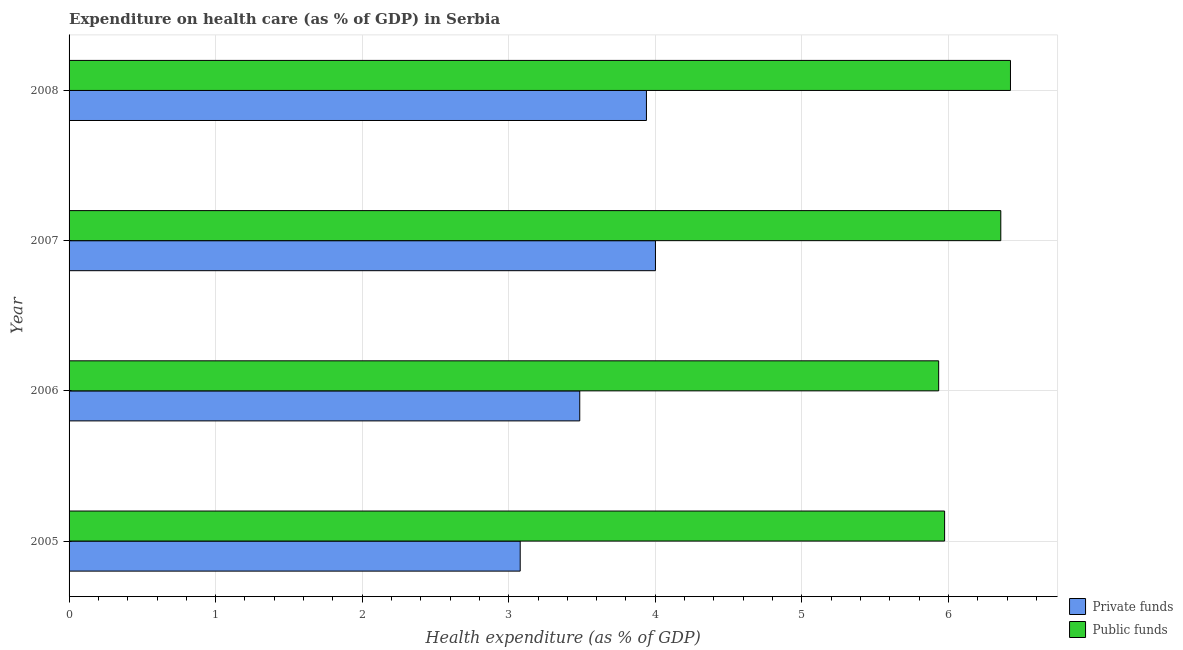Are the number of bars on each tick of the Y-axis equal?
Give a very brief answer. Yes. How many bars are there on the 1st tick from the top?
Your response must be concise. 2. How many bars are there on the 2nd tick from the bottom?
Provide a short and direct response. 2. In how many cases, is the number of bars for a given year not equal to the number of legend labels?
Provide a short and direct response. 0. What is the amount of private funds spent in healthcare in 2007?
Provide a succinct answer. 4. Across all years, what is the maximum amount of private funds spent in healthcare?
Your response must be concise. 4. Across all years, what is the minimum amount of public funds spent in healthcare?
Your response must be concise. 5.93. In which year was the amount of public funds spent in healthcare maximum?
Provide a succinct answer. 2008. In which year was the amount of private funds spent in healthcare minimum?
Your response must be concise. 2005. What is the total amount of public funds spent in healthcare in the graph?
Give a very brief answer. 24.69. What is the difference between the amount of public funds spent in healthcare in 2007 and that in 2008?
Provide a succinct answer. -0.07. What is the difference between the amount of public funds spent in healthcare in 2006 and the amount of private funds spent in healthcare in 2007?
Your response must be concise. 1.93. What is the average amount of private funds spent in healthcare per year?
Offer a terse response. 3.63. In the year 2008, what is the difference between the amount of private funds spent in healthcare and amount of public funds spent in healthcare?
Offer a terse response. -2.48. In how many years, is the amount of public funds spent in healthcare greater than 5.2 %?
Offer a terse response. 4. Is the difference between the amount of public funds spent in healthcare in 2005 and 2006 greater than the difference between the amount of private funds spent in healthcare in 2005 and 2006?
Offer a terse response. Yes. What is the difference between the highest and the second highest amount of public funds spent in healthcare?
Provide a short and direct response. 0.07. What is the difference between the highest and the lowest amount of public funds spent in healthcare?
Your answer should be very brief. 0.49. What does the 1st bar from the top in 2005 represents?
Ensure brevity in your answer.  Public funds. What does the 2nd bar from the bottom in 2006 represents?
Make the answer very short. Public funds. Are all the bars in the graph horizontal?
Make the answer very short. Yes. Are the values on the major ticks of X-axis written in scientific E-notation?
Make the answer very short. No. Does the graph contain any zero values?
Offer a very short reply. No. Does the graph contain grids?
Ensure brevity in your answer.  Yes. Where does the legend appear in the graph?
Give a very brief answer. Bottom right. What is the title of the graph?
Provide a short and direct response. Expenditure on health care (as % of GDP) in Serbia. Does "Resident workers" appear as one of the legend labels in the graph?
Give a very brief answer. No. What is the label or title of the X-axis?
Ensure brevity in your answer.  Health expenditure (as % of GDP). What is the label or title of the Y-axis?
Give a very brief answer. Year. What is the Health expenditure (as % of GDP) in Private funds in 2005?
Provide a short and direct response. 3.08. What is the Health expenditure (as % of GDP) of Public funds in 2005?
Your answer should be compact. 5.97. What is the Health expenditure (as % of GDP) of Private funds in 2006?
Your answer should be compact. 3.48. What is the Health expenditure (as % of GDP) in Public funds in 2006?
Give a very brief answer. 5.93. What is the Health expenditure (as % of GDP) in Private funds in 2007?
Your answer should be very brief. 4. What is the Health expenditure (as % of GDP) of Public funds in 2007?
Offer a terse response. 6.36. What is the Health expenditure (as % of GDP) in Private funds in 2008?
Your answer should be very brief. 3.94. What is the Health expenditure (as % of GDP) in Public funds in 2008?
Offer a very short reply. 6.42. Across all years, what is the maximum Health expenditure (as % of GDP) in Private funds?
Ensure brevity in your answer.  4. Across all years, what is the maximum Health expenditure (as % of GDP) of Public funds?
Provide a succinct answer. 6.42. Across all years, what is the minimum Health expenditure (as % of GDP) in Private funds?
Your answer should be very brief. 3.08. Across all years, what is the minimum Health expenditure (as % of GDP) of Public funds?
Make the answer very short. 5.93. What is the total Health expenditure (as % of GDP) of Private funds in the graph?
Give a very brief answer. 14.5. What is the total Health expenditure (as % of GDP) in Public funds in the graph?
Your answer should be very brief. 24.69. What is the difference between the Health expenditure (as % of GDP) in Private funds in 2005 and that in 2006?
Offer a terse response. -0.41. What is the difference between the Health expenditure (as % of GDP) of Public funds in 2005 and that in 2006?
Your answer should be compact. 0.04. What is the difference between the Health expenditure (as % of GDP) in Private funds in 2005 and that in 2007?
Your answer should be compact. -0.92. What is the difference between the Health expenditure (as % of GDP) in Public funds in 2005 and that in 2007?
Ensure brevity in your answer.  -0.38. What is the difference between the Health expenditure (as % of GDP) of Private funds in 2005 and that in 2008?
Ensure brevity in your answer.  -0.86. What is the difference between the Health expenditure (as % of GDP) of Public funds in 2005 and that in 2008?
Give a very brief answer. -0.45. What is the difference between the Health expenditure (as % of GDP) of Private funds in 2006 and that in 2007?
Make the answer very short. -0.52. What is the difference between the Health expenditure (as % of GDP) in Public funds in 2006 and that in 2007?
Your answer should be very brief. -0.42. What is the difference between the Health expenditure (as % of GDP) of Private funds in 2006 and that in 2008?
Keep it short and to the point. -0.46. What is the difference between the Health expenditure (as % of GDP) of Public funds in 2006 and that in 2008?
Your answer should be compact. -0.49. What is the difference between the Health expenditure (as % of GDP) in Private funds in 2007 and that in 2008?
Give a very brief answer. 0.06. What is the difference between the Health expenditure (as % of GDP) in Public funds in 2007 and that in 2008?
Your answer should be very brief. -0.07. What is the difference between the Health expenditure (as % of GDP) of Private funds in 2005 and the Health expenditure (as % of GDP) of Public funds in 2006?
Give a very brief answer. -2.86. What is the difference between the Health expenditure (as % of GDP) of Private funds in 2005 and the Health expenditure (as % of GDP) of Public funds in 2007?
Offer a very short reply. -3.28. What is the difference between the Health expenditure (as % of GDP) in Private funds in 2005 and the Health expenditure (as % of GDP) in Public funds in 2008?
Your response must be concise. -3.35. What is the difference between the Health expenditure (as % of GDP) of Private funds in 2006 and the Health expenditure (as % of GDP) of Public funds in 2007?
Your answer should be very brief. -2.87. What is the difference between the Health expenditure (as % of GDP) in Private funds in 2006 and the Health expenditure (as % of GDP) in Public funds in 2008?
Your answer should be very brief. -2.94. What is the difference between the Health expenditure (as % of GDP) of Private funds in 2007 and the Health expenditure (as % of GDP) of Public funds in 2008?
Ensure brevity in your answer.  -2.42. What is the average Health expenditure (as % of GDP) of Private funds per year?
Ensure brevity in your answer.  3.63. What is the average Health expenditure (as % of GDP) of Public funds per year?
Ensure brevity in your answer.  6.17. In the year 2005, what is the difference between the Health expenditure (as % of GDP) in Private funds and Health expenditure (as % of GDP) in Public funds?
Provide a succinct answer. -2.9. In the year 2006, what is the difference between the Health expenditure (as % of GDP) of Private funds and Health expenditure (as % of GDP) of Public funds?
Your answer should be compact. -2.45. In the year 2007, what is the difference between the Health expenditure (as % of GDP) in Private funds and Health expenditure (as % of GDP) in Public funds?
Provide a succinct answer. -2.36. In the year 2008, what is the difference between the Health expenditure (as % of GDP) of Private funds and Health expenditure (as % of GDP) of Public funds?
Your answer should be compact. -2.48. What is the ratio of the Health expenditure (as % of GDP) in Private funds in 2005 to that in 2006?
Your answer should be very brief. 0.88. What is the ratio of the Health expenditure (as % of GDP) of Public funds in 2005 to that in 2006?
Offer a very short reply. 1.01. What is the ratio of the Health expenditure (as % of GDP) in Private funds in 2005 to that in 2007?
Provide a short and direct response. 0.77. What is the ratio of the Health expenditure (as % of GDP) of Public funds in 2005 to that in 2007?
Provide a succinct answer. 0.94. What is the ratio of the Health expenditure (as % of GDP) of Private funds in 2005 to that in 2008?
Give a very brief answer. 0.78. What is the ratio of the Health expenditure (as % of GDP) of Public funds in 2005 to that in 2008?
Ensure brevity in your answer.  0.93. What is the ratio of the Health expenditure (as % of GDP) of Private funds in 2006 to that in 2007?
Offer a terse response. 0.87. What is the ratio of the Health expenditure (as % of GDP) in Private funds in 2006 to that in 2008?
Keep it short and to the point. 0.88. What is the ratio of the Health expenditure (as % of GDP) of Public funds in 2006 to that in 2008?
Your response must be concise. 0.92. What is the ratio of the Health expenditure (as % of GDP) in Private funds in 2007 to that in 2008?
Your response must be concise. 1.02. What is the difference between the highest and the second highest Health expenditure (as % of GDP) of Private funds?
Provide a succinct answer. 0.06. What is the difference between the highest and the second highest Health expenditure (as % of GDP) of Public funds?
Provide a succinct answer. 0.07. What is the difference between the highest and the lowest Health expenditure (as % of GDP) in Private funds?
Offer a terse response. 0.92. What is the difference between the highest and the lowest Health expenditure (as % of GDP) in Public funds?
Provide a short and direct response. 0.49. 